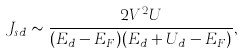<formula> <loc_0><loc_0><loc_500><loc_500>J _ { s d } \sim \frac { 2 V ^ { 2 } U } { ( E _ { d } - E _ { F } ) ( E _ { d } + U _ { d } - E _ { F } ) } ,</formula> 